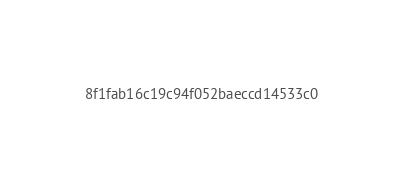<code> <loc_0><loc_0><loc_500><loc_500><_HTML_>8f1fab16c19c94f052baeccd14533c0</code> 